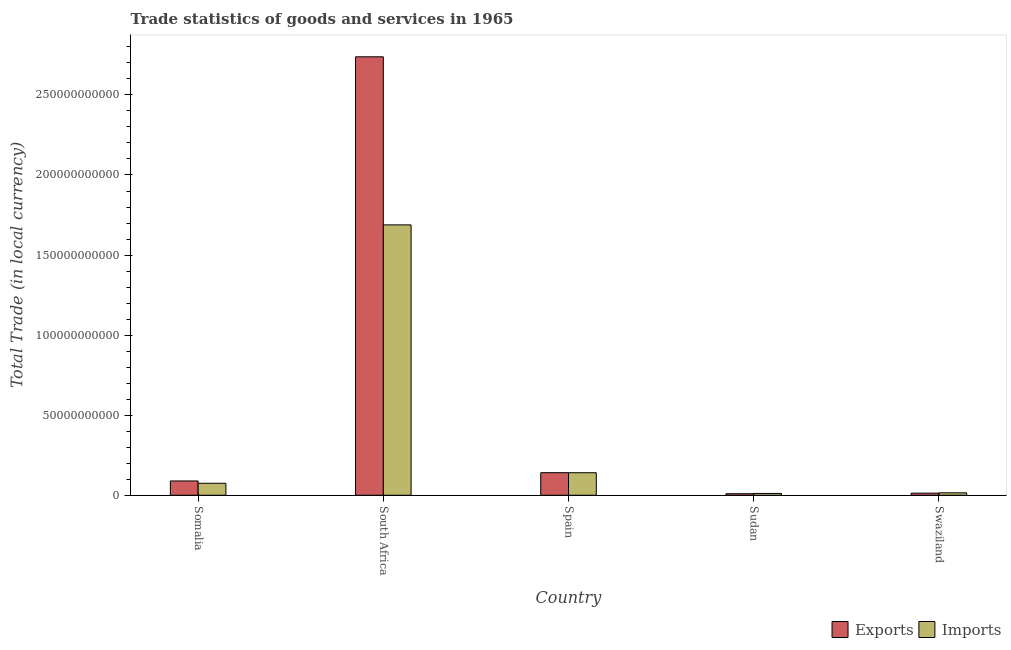How many different coloured bars are there?
Keep it short and to the point. 2. Are the number of bars per tick equal to the number of legend labels?
Your answer should be very brief. Yes. Are the number of bars on each tick of the X-axis equal?
Give a very brief answer. Yes. How many bars are there on the 1st tick from the left?
Provide a succinct answer. 2. What is the label of the 5th group of bars from the left?
Provide a succinct answer. Swaziland. What is the export of goods and services in Swaziland?
Your response must be concise. 1.30e+09. Across all countries, what is the maximum export of goods and services?
Provide a short and direct response. 2.74e+11. Across all countries, what is the minimum imports of goods and services?
Ensure brevity in your answer.  1.12e+09. In which country was the export of goods and services maximum?
Provide a short and direct response. South Africa. In which country was the imports of goods and services minimum?
Offer a very short reply. Sudan. What is the total imports of goods and services in the graph?
Offer a terse response. 1.93e+11. What is the difference between the export of goods and services in South Africa and that in Sudan?
Your response must be concise. 2.73e+11. What is the difference between the export of goods and services in Swaziland and the imports of goods and services in South Africa?
Offer a very short reply. -1.68e+11. What is the average export of goods and services per country?
Your answer should be very brief. 5.98e+1. What is the difference between the export of goods and services and imports of goods and services in South Africa?
Give a very brief answer. 1.05e+11. What is the ratio of the imports of goods and services in Sudan to that in Swaziland?
Make the answer very short. 0.75. Is the export of goods and services in South Africa less than that in Spain?
Ensure brevity in your answer.  No. Is the difference between the export of goods and services in South Africa and Spain greater than the difference between the imports of goods and services in South Africa and Spain?
Offer a very short reply. Yes. What is the difference between the highest and the second highest imports of goods and services?
Give a very brief answer. 1.55e+11. What is the difference between the highest and the lowest export of goods and services?
Your response must be concise. 2.73e+11. What does the 1st bar from the left in Somalia represents?
Provide a succinct answer. Exports. What does the 2nd bar from the right in Somalia represents?
Offer a terse response. Exports. Are all the bars in the graph horizontal?
Ensure brevity in your answer.  No. How many countries are there in the graph?
Your answer should be very brief. 5. Are the values on the major ticks of Y-axis written in scientific E-notation?
Your answer should be compact. No. What is the title of the graph?
Give a very brief answer. Trade statistics of goods and services in 1965. What is the label or title of the X-axis?
Your response must be concise. Country. What is the label or title of the Y-axis?
Offer a very short reply. Total Trade (in local currency). What is the Total Trade (in local currency) in Exports in Somalia?
Keep it short and to the point. 8.91e+09. What is the Total Trade (in local currency) in Imports in Somalia?
Ensure brevity in your answer.  7.49e+09. What is the Total Trade (in local currency) in Exports in South Africa?
Your answer should be compact. 2.74e+11. What is the Total Trade (in local currency) in Imports in South Africa?
Give a very brief answer. 1.69e+11. What is the Total Trade (in local currency) of Exports in Spain?
Your answer should be compact. 1.41e+1. What is the Total Trade (in local currency) in Imports in Spain?
Offer a terse response. 1.41e+1. What is the Total Trade (in local currency) of Exports in Sudan?
Your response must be concise. 9.48e+08. What is the Total Trade (in local currency) of Imports in Sudan?
Provide a short and direct response. 1.12e+09. What is the Total Trade (in local currency) of Exports in Swaziland?
Your response must be concise. 1.30e+09. What is the Total Trade (in local currency) in Imports in Swaziland?
Your answer should be compact. 1.51e+09. Across all countries, what is the maximum Total Trade (in local currency) in Exports?
Give a very brief answer. 2.74e+11. Across all countries, what is the maximum Total Trade (in local currency) of Imports?
Offer a terse response. 1.69e+11. Across all countries, what is the minimum Total Trade (in local currency) of Exports?
Your answer should be compact. 9.48e+08. Across all countries, what is the minimum Total Trade (in local currency) in Imports?
Provide a succinct answer. 1.12e+09. What is the total Total Trade (in local currency) of Exports in the graph?
Keep it short and to the point. 2.99e+11. What is the total Total Trade (in local currency) of Imports in the graph?
Provide a short and direct response. 1.93e+11. What is the difference between the Total Trade (in local currency) of Exports in Somalia and that in South Africa?
Provide a succinct answer. -2.65e+11. What is the difference between the Total Trade (in local currency) of Imports in Somalia and that in South Africa?
Make the answer very short. -1.61e+11. What is the difference between the Total Trade (in local currency) in Exports in Somalia and that in Spain?
Your answer should be very brief. -5.17e+09. What is the difference between the Total Trade (in local currency) in Imports in Somalia and that in Spain?
Make the answer very short. -6.58e+09. What is the difference between the Total Trade (in local currency) in Exports in Somalia and that in Sudan?
Keep it short and to the point. 7.97e+09. What is the difference between the Total Trade (in local currency) in Imports in Somalia and that in Sudan?
Offer a very short reply. 6.36e+09. What is the difference between the Total Trade (in local currency) in Exports in Somalia and that in Swaziland?
Give a very brief answer. 7.61e+09. What is the difference between the Total Trade (in local currency) in Imports in Somalia and that in Swaziland?
Provide a short and direct response. 5.98e+09. What is the difference between the Total Trade (in local currency) of Exports in South Africa and that in Spain?
Offer a very short reply. 2.60e+11. What is the difference between the Total Trade (in local currency) in Imports in South Africa and that in Spain?
Offer a terse response. 1.55e+11. What is the difference between the Total Trade (in local currency) in Exports in South Africa and that in Sudan?
Ensure brevity in your answer.  2.73e+11. What is the difference between the Total Trade (in local currency) of Imports in South Africa and that in Sudan?
Provide a short and direct response. 1.68e+11. What is the difference between the Total Trade (in local currency) of Exports in South Africa and that in Swaziland?
Your response must be concise. 2.73e+11. What is the difference between the Total Trade (in local currency) of Imports in South Africa and that in Swaziland?
Provide a succinct answer. 1.67e+11. What is the difference between the Total Trade (in local currency) of Exports in Spain and that in Sudan?
Your answer should be compact. 1.31e+1. What is the difference between the Total Trade (in local currency) of Imports in Spain and that in Sudan?
Offer a very short reply. 1.29e+1. What is the difference between the Total Trade (in local currency) in Exports in Spain and that in Swaziland?
Your answer should be compact. 1.28e+1. What is the difference between the Total Trade (in local currency) of Imports in Spain and that in Swaziland?
Ensure brevity in your answer.  1.26e+1. What is the difference between the Total Trade (in local currency) of Exports in Sudan and that in Swaziland?
Keep it short and to the point. -3.54e+08. What is the difference between the Total Trade (in local currency) of Imports in Sudan and that in Swaziland?
Your response must be concise. -3.82e+08. What is the difference between the Total Trade (in local currency) in Exports in Somalia and the Total Trade (in local currency) in Imports in South Africa?
Offer a very short reply. -1.60e+11. What is the difference between the Total Trade (in local currency) of Exports in Somalia and the Total Trade (in local currency) of Imports in Spain?
Make the answer very short. -5.15e+09. What is the difference between the Total Trade (in local currency) of Exports in Somalia and the Total Trade (in local currency) of Imports in Sudan?
Ensure brevity in your answer.  7.79e+09. What is the difference between the Total Trade (in local currency) in Exports in Somalia and the Total Trade (in local currency) in Imports in Swaziland?
Provide a short and direct response. 7.41e+09. What is the difference between the Total Trade (in local currency) of Exports in South Africa and the Total Trade (in local currency) of Imports in Spain?
Give a very brief answer. 2.60e+11. What is the difference between the Total Trade (in local currency) of Exports in South Africa and the Total Trade (in local currency) of Imports in Sudan?
Ensure brevity in your answer.  2.73e+11. What is the difference between the Total Trade (in local currency) in Exports in South Africa and the Total Trade (in local currency) in Imports in Swaziland?
Give a very brief answer. 2.72e+11. What is the difference between the Total Trade (in local currency) of Exports in Spain and the Total Trade (in local currency) of Imports in Sudan?
Keep it short and to the point. 1.30e+1. What is the difference between the Total Trade (in local currency) of Exports in Spain and the Total Trade (in local currency) of Imports in Swaziland?
Offer a terse response. 1.26e+1. What is the difference between the Total Trade (in local currency) of Exports in Sudan and the Total Trade (in local currency) of Imports in Swaziland?
Your response must be concise. -5.59e+08. What is the average Total Trade (in local currency) in Exports per country?
Your answer should be compact. 5.98e+1. What is the average Total Trade (in local currency) of Imports per country?
Keep it short and to the point. 3.86e+1. What is the difference between the Total Trade (in local currency) of Exports and Total Trade (in local currency) of Imports in Somalia?
Offer a terse response. 1.43e+09. What is the difference between the Total Trade (in local currency) of Exports and Total Trade (in local currency) of Imports in South Africa?
Provide a short and direct response. 1.05e+11. What is the difference between the Total Trade (in local currency) in Exports and Total Trade (in local currency) in Imports in Spain?
Offer a terse response. 2.56e+07. What is the difference between the Total Trade (in local currency) of Exports and Total Trade (in local currency) of Imports in Sudan?
Offer a very short reply. -1.77e+08. What is the difference between the Total Trade (in local currency) in Exports and Total Trade (in local currency) in Imports in Swaziland?
Provide a short and direct response. -2.04e+08. What is the ratio of the Total Trade (in local currency) of Exports in Somalia to that in South Africa?
Offer a very short reply. 0.03. What is the ratio of the Total Trade (in local currency) of Imports in Somalia to that in South Africa?
Ensure brevity in your answer.  0.04. What is the ratio of the Total Trade (in local currency) in Exports in Somalia to that in Spain?
Ensure brevity in your answer.  0.63. What is the ratio of the Total Trade (in local currency) in Imports in Somalia to that in Spain?
Your answer should be very brief. 0.53. What is the ratio of the Total Trade (in local currency) in Exports in Somalia to that in Sudan?
Provide a succinct answer. 9.4. What is the ratio of the Total Trade (in local currency) in Imports in Somalia to that in Sudan?
Provide a succinct answer. 6.66. What is the ratio of the Total Trade (in local currency) in Exports in Somalia to that in Swaziland?
Keep it short and to the point. 6.85. What is the ratio of the Total Trade (in local currency) in Imports in Somalia to that in Swaziland?
Ensure brevity in your answer.  4.97. What is the ratio of the Total Trade (in local currency) in Exports in South Africa to that in Spain?
Your response must be concise. 19.44. What is the ratio of the Total Trade (in local currency) in Imports in South Africa to that in Spain?
Ensure brevity in your answer.  12.01. What is the ratio of the Total Trade (in local currency) in Exports in South Africa to that in Sudan?
Your answer should be compact. 288.91. What is the ratio of the Total Trade (in local currency) in Imports in South Africa to that in Sudan?
Offer a very short reply. 150.18. What is the ratio of the Total Trade (in local currency) of Exports in South Africa to that in Swaziland?
Provide a succinct answer. 210.29. What is the ratio of the Total Trade (in local currency) in Imports in South Africa to that in Swaziland?
Ensure brevity in your answer.  112.09. What is the ratio of the Total Trade (in local currency) in Exports in Spain to that in Sudan?
Offer a very short reply. 14.86. What is the ratio of the Total Trade (in local currency) in Imports in Spain to that in Sudan?
Give a very brief answer. 12.51. What is the ratio of the Total Trade (in local currency) in Exports in Spain to that in Swaziland?
Your answer should be very brief. 10.82. What is the ratio of the Total Trade (in local currency) of Imports in Spain to that in Swaziland?
Your response must be concise. 9.34. What is the ratio of the Total Trade (in local currency) of Exports in Sudan to that in Swaziland?
Ensure brevity in your answer.  0.73. What is the ratio of the Total Trade (in local currency) of Imports in Sudan to that in Swaziland?
Keep it short and to the point. 0.75. What is the difference between the highest and the second highest Total Trade (in local currency) of Exports?
Your answer should be very brief. 2.60e+11. What is the difference between the highest and the second highest Total Trade (in local currency) in Imports?
Provide a short and direct response. 1.55e+11. What is the difference between the highest and the lowest Total Trade (in local currency) in Exports?
Your response must be concise. 2.73e+11. What is the difference between the highest and the lowest Total Trade (in local currency) in Imports?
Provide a succinct answer. 1.68e+11. 